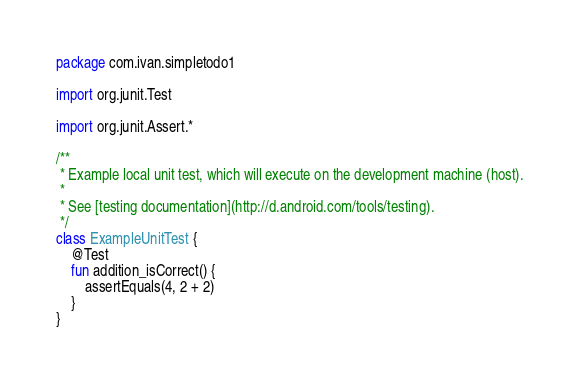<code> <loc_0><loc_0><loc_500><loc_500><_Kotlin_>package com.ivan.simpletodo1

import org.junit.Test

import org.junit.Assert.*

/**
 * Example local unit test, which will execute on the development machine (host).
 *
 * See [testing documentation](http://d.android.com/tools/testing).
 */
class ExampleUnitTest {
    @Test
    fun addition_isCorrect() {
        assertEquals(4, 2 + 2)
    }
}</code> 